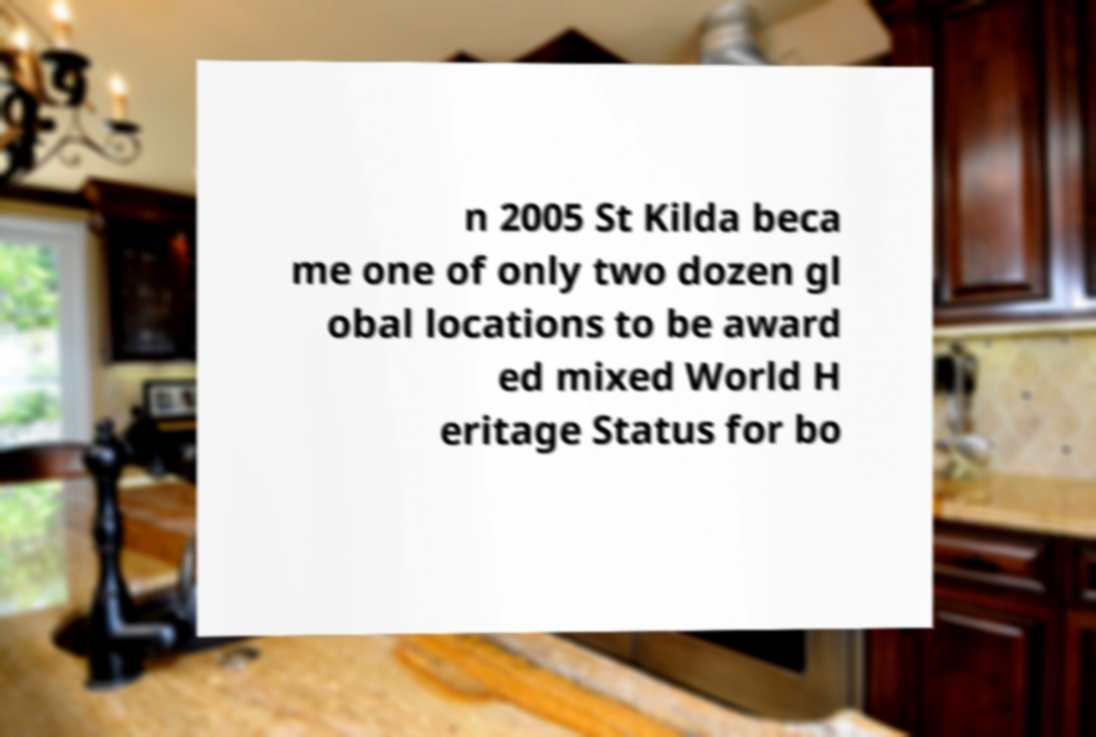For documentation purposes, I need the text within this image transcribed. Could you provide that? n 2005 St Kilda beca me one of only two dozen gl obal locations to be award ed mixed World H eritage Status for bo 